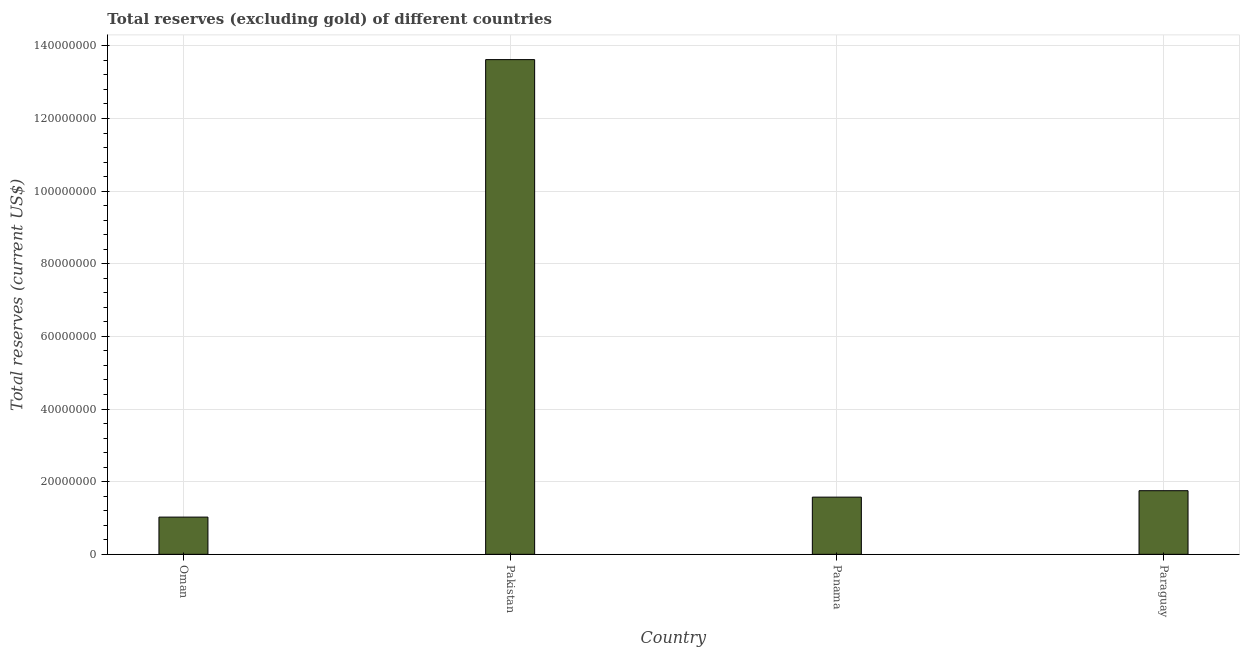Does the graph contain any zero values?
Make the answer very short. No. Does the graph contain grids?
Provide a short and direct response. Yes. What is the title of the graph?
Ensure brevity in your answer.  Total reserves (excluding gold) of different countries. What is the label or title of the X-axis?
Your answer should be compact. Country. What is the label or title of the Y-axis?
Your answer should be compact. Total reserves (current US$). What is the total reserves (excluding gold) in Paraguay?
Offer a very short reply. 1.75e+07. Across all countries, what is the maximum total reserves (excluding gold)?
Give a very brief answer. 1.36e+08. Across all countries, what is the minimum total reserves (excluding gold)?
Ensure brevity in your answer.  1.02e+07. In which country was the total reserves (excluding gold) maximum?
Offer a terse response. Pakistan. In which country was the total reserves (excluding gold) minimum?
Give a very brief answer. Oman. What is the sum of the total reserves (excluding gold)?
Your response must be concise. 1.80e+08. What is the difference between the total reserves (excluding gold) in Pakistan and Panama?
Your response must be concise. 1.20e+08. What is the average total reserves (excluding gold) per country?
Keep it short and to the point. 4.49e+07. What is the median total reserves (excluding gold)?
Your answer should be very brief. 1.66e+07. What is the ratio of the total reserves (excluding gold) in Pakistan to that in Panama?
Provide a short and direct response. 8.65. Is the total reserves (excluding gold) in Panama less than that in Paraguay?
Keep it short and to the point. Yes. What is the difference between the highest and the second highest total reserves (excluding gold)?
Ensure brevity in your answer.  1.19e+08. Is the sum of the total reserves (excluding gold) in Oman and Panama greater than the maximum total reserves (excluding gold) across all countries?
Keep it short and to the point. No. What is the difference between the highest and the lowest total reserves (excluding gold)?
Keep it short and to the point. 1.26e+08. How many bars are there?
Give a very brief answer. 4. How many countries are there in the graph?
Ensure brevity in your answer.  4. What is the Total reserves (current US$) in Oman?
Offer a very short reply. 1.02e+07. What is the Total reserves (current US$) in Pakistan?
Your answer should be compact. 1.36e+08. What is the Total reserves (current US$) of Panama?
Give a very brief answer. 1.57e+07. What is the Total reserves (current US$) in Paraguay?
Keep it short and to the point. 1.75e+07. What is the difference between the Total reserves (current US$) in Oman and Pakistan?
Offer a terse response. -1.26e+08. What is the difference between the Total reserves (current US$) in Oman and Panama?
Give a very brief answer. -5.50e+06. What is the difference between the Total reserves (current US$) in Oman and Paraguay?
Offer a very short reply. -7.27e+06. What is the difference between the Total reserves (current US$) in Pakistan and Panama?
Your answer should be very brief. 1.20e+08. What is the difference between the Total reserves (current US$) in Pakistan and Paraguay?
Provide a succinct answer. 1.19e+08. What is the difference between the Total reserves (current US$) in Panama and Paraguay?
Your answer should be compact. -1.77e+06. What is the ratio of the Total reserves (current US$) in Oman to that in Pakistan?
Provide a short and direct response. 0.07. What is the ratio of the Total reserves (current US$) in Oman to that in Panama?
Your answer should be compact. 0.65. What is the ratio of the Total reserves (current US$) in Oman to that in Paraguay?
Offer a very short reply. 0.58. What is the ratio of the Total reserves (current US$) in Pakistan to that in Panama?
Your response must be concise. 8.65. What is the ratio of the Total reserves (current US$) in Pakistan to that in Paraguay?
Provide a succinct answer. 7.78. What is the ratio of the Total reserves (current US$) in Panama to that in Paraguay?
Give a very brief answer. 0.9. 